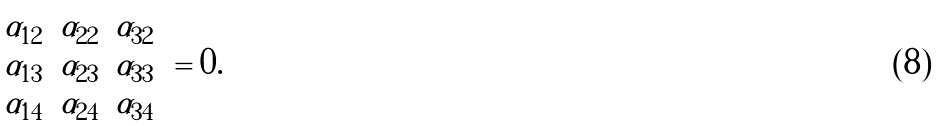<formula> <loc_0><loc_0><loc_500><loc_500>\left | \begin{array} { c c c } \alpha _ { 1 2 } & \alpha _ { 2 2 } & \alpha _ { 3 2 } \\ \alpha _ { 1 3 } & \alpha _ { 2 3 } & \alpha _ { 3 3 } \\ \alpha _ { 1 4 } & \alpha _ { 2 4 } & \alpha _ { 3 4 } \\ \end{array} \right | = 0 .</formula> 